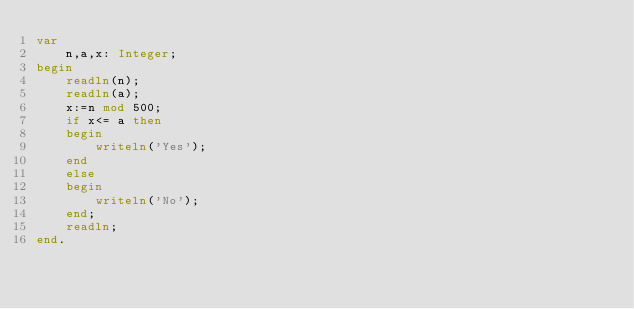<code> <loc_0><loc_0><loc_500><loc_500><_Pascal_>var
    n,a,x: Integer;
begin
    readln(n);
    readln(a);
    x:=n mod 500;
    if x<= a then 
    begin
        writeln('Yes');
    end
    else 
    begin
        writeln('No');
    end;
    readln;
end.</code> 